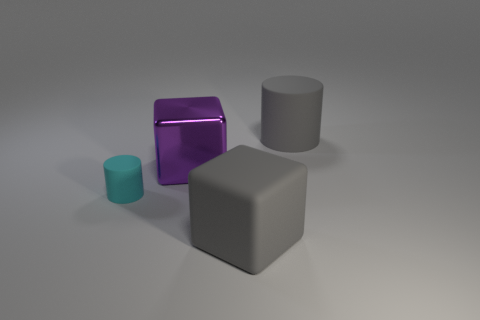What could be the function of the purple object in the image? The purple object may serve as a decorative piece, possibly crafted from glass or transparent plastic, given its reflective surface and aesthetic appeal. Its function seems more ornamental than practical. 